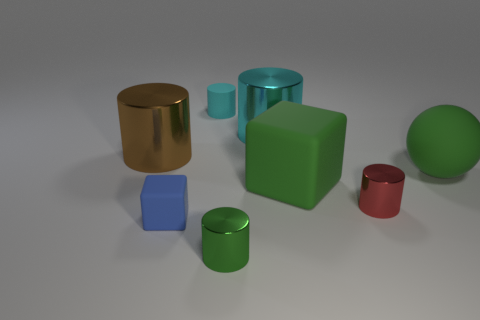Subtract all cyan metal cylinders. How many cylinders are left? 4 Add 1 tiny red cylinders. How many objects exist? 9 Subtract 2 cubes. How many cubes are left? 0 Subtract all cyan cylinders. How many cylinders are left? 3 Subtract all yellow spheres. How many cyan cylinders are left? 2 Add 3 matte things. How many matte things are left? 7 Add 1 blue matte cubes. How many blue matte cubes exist? 2 Subtract 0 red cubes. How many objects are left? 8 Subtract all spheres. How many objects are left? 7 Subtract all blue balls. Subtract all blue cylinders. How many balls are left? 1 